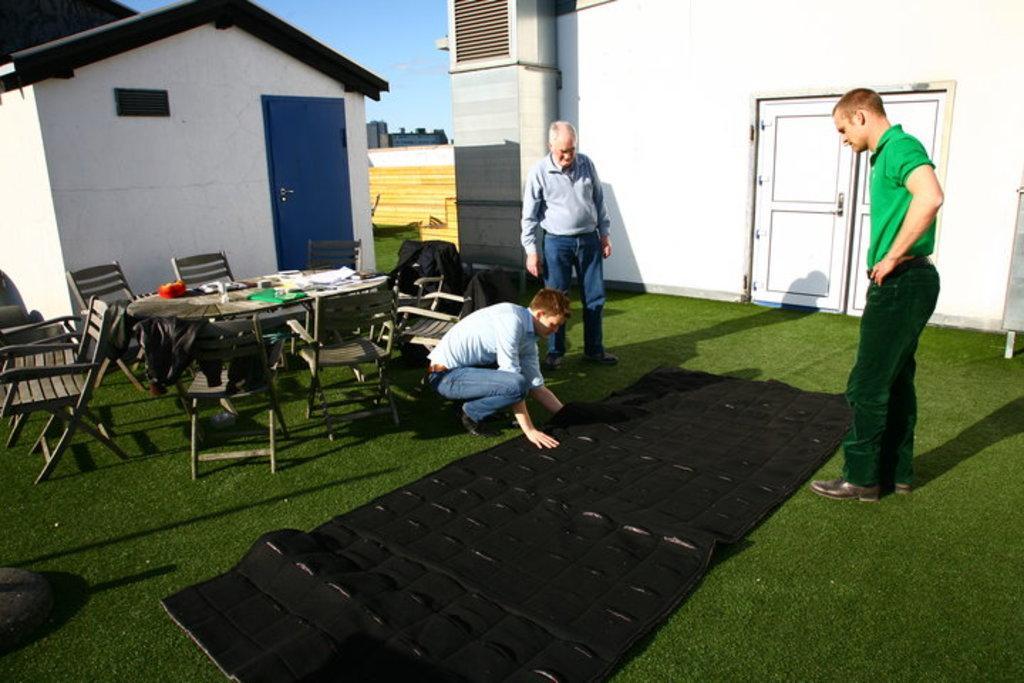How would you summarize this image in a sentence or two? In this picture we see two houses and three men and a green grass and a table and Few chairs 